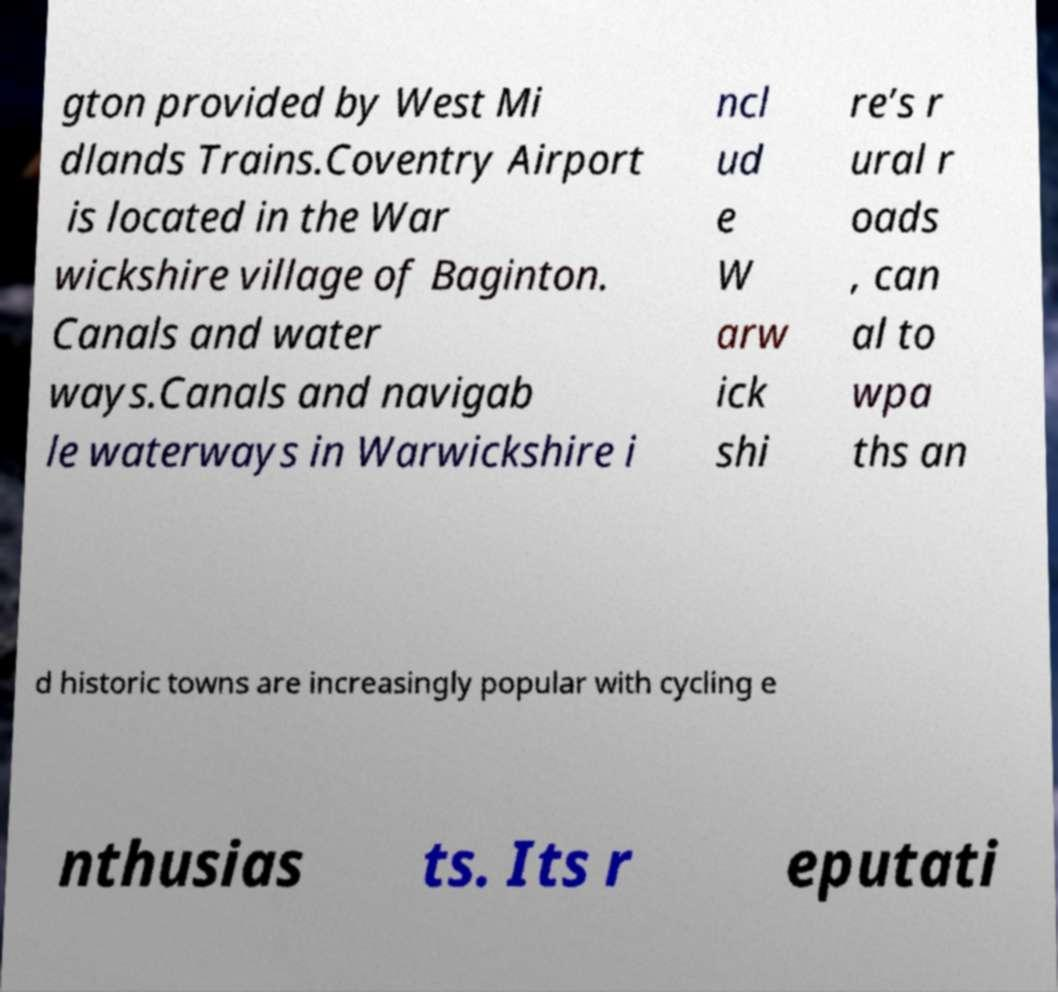For documentation purposes, I need the text within this image transcribed. Could you provide that? gton provided by West Mi dlands Trains.Coventry Airport is located in the War wickshire village of Baginton. Canals and water ways.Canals and navigab le waterways in Warwickshire i ncl ud e W arw ick shi re’s r ural r oads , can al to wpa ths an d historic towns are increasingly popular with cycling e nthusias ts. Its r eputati 